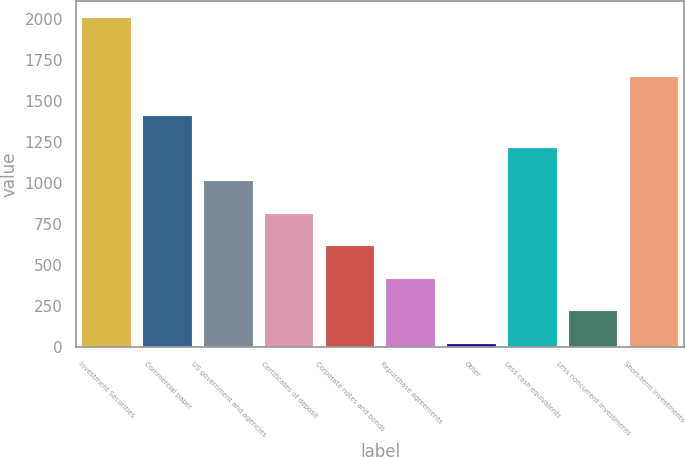Convert chart to OTSL. <chart><loc_0><loc_0><loc_500><loc_500><bar_chart><fcel>Investment Securities<fcel>Commercial paper<fcel>US government and agencies<fcel>Certificates of deposit<fcel>Corporate notes and bonds<fcel>Repurchase agreements<fcel>Other<fcel>Less cash equivalents<fcel>Less noncurrent investments<fcel>Short-term investments<nl><fcel>2006<fcel>1410.5<fcel>1013.5<fcel>815<fcel>616.5<fcel>418<fcel>21<fcel>1212<fcel>219.5<fcel>1648<nl></chart> 